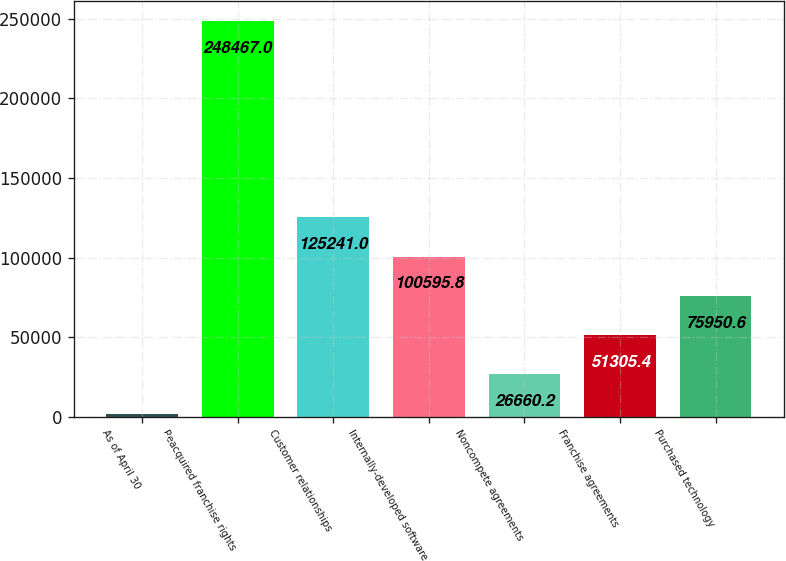Convert chart. <chart><loc_0><loc_0><loc_500><loc_500><bar_chart><fcel>As of April 30<fcel>Reacquired franchise rights<fcel>Customer relationships<fcel>Internally-developed software<fcel>Noncompete agreements<fcel>Franchise agreements<fcel>Purchased technology<nl><fcel>2015<fcel>248467<fcel>125241<fcel>100596<fcel>26660.2<fcel>51305.4<fcel>75950.6<nl></chart> 